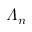<formula> <loc_0><loc_0><loc_500><loc_500>\varLambda _ { n }</formula> 